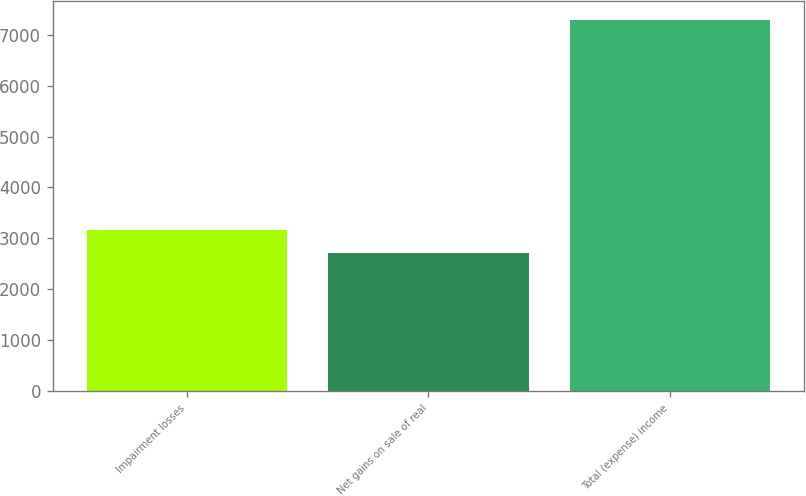<chart> <loc_0><loc_0><loc_500><loc_500><bar_chart><fcel>Impairment losses<fcel>Net gains on sale of real<fcel>Total (expense) income<nl><fcel>3164.3<fcel>2705<fcel>7298<nl></chart> 